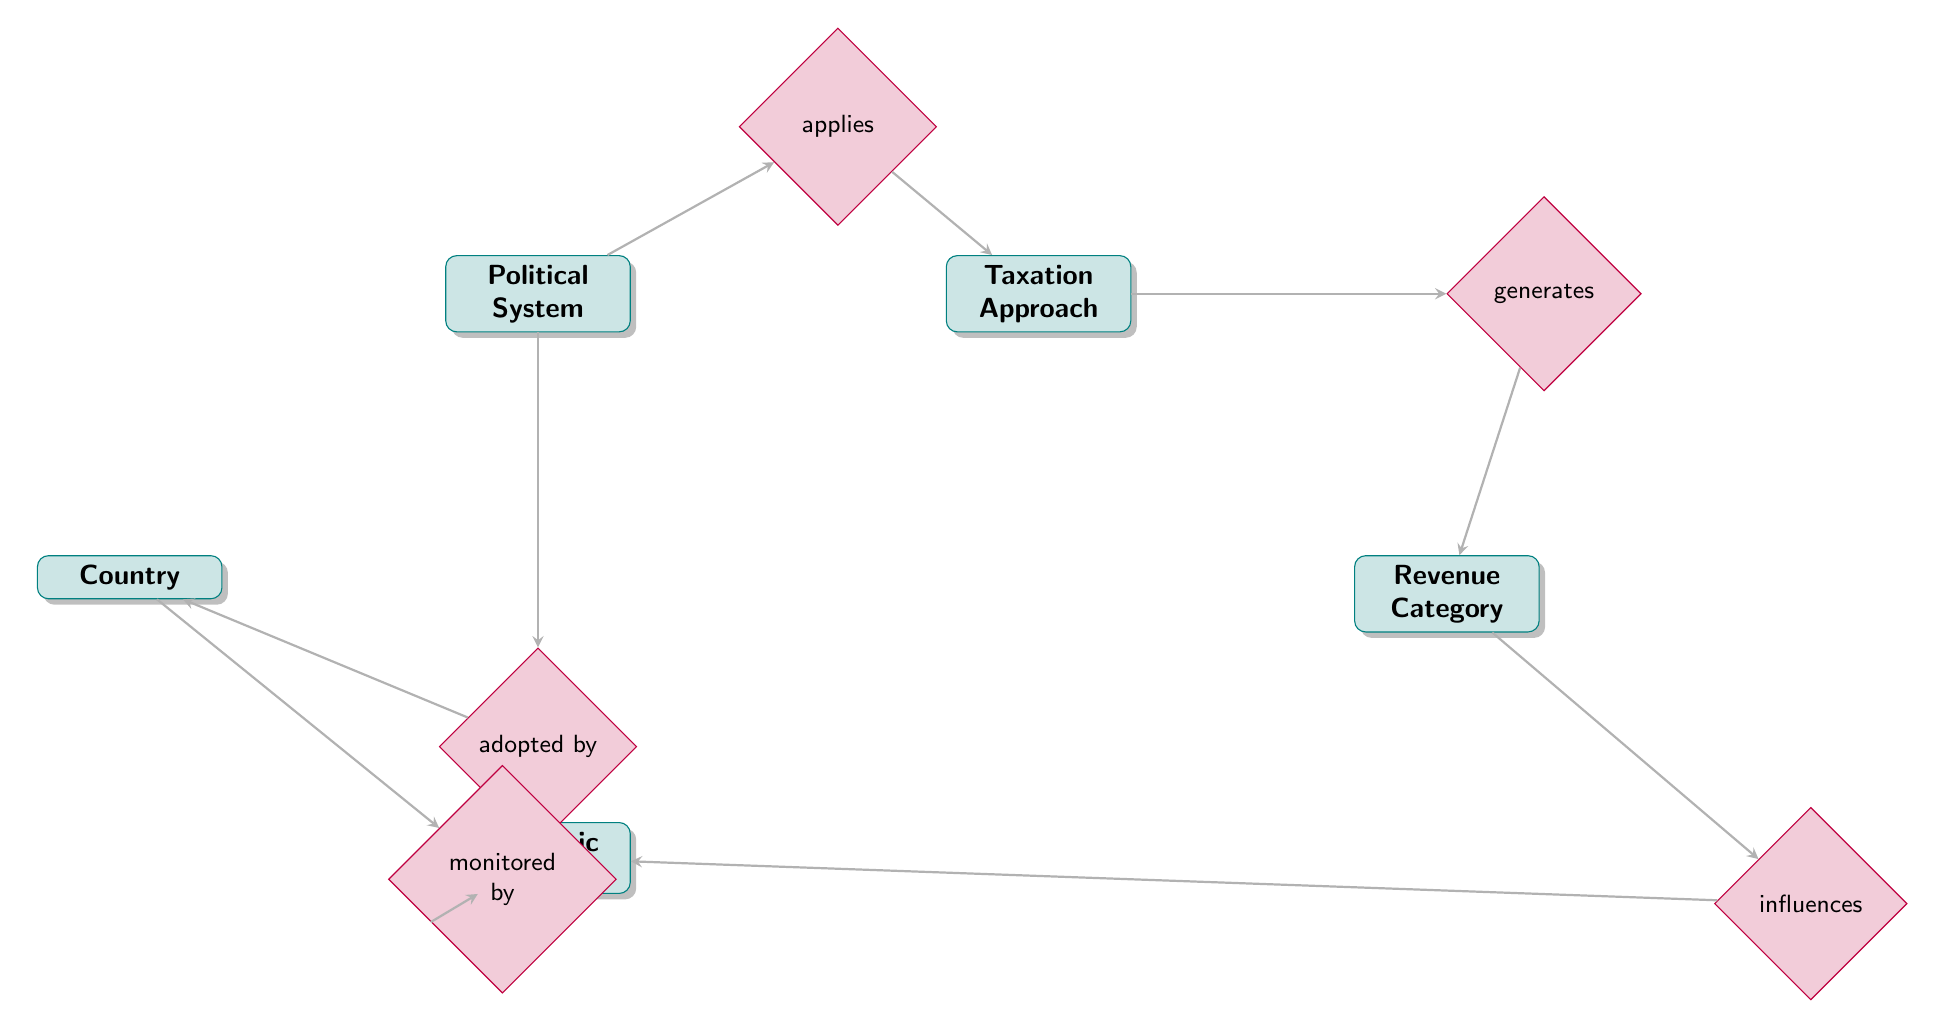What is the main entity representing different governance types? The main entity that represents various governance types in the diagram is labeled as "Political System."
Answer: Political System How many entities are connected to the "Taxation Approach" entity? The "Taxation Approach" entity is connected to two other entities: "Political System" and "Revenue Category" through the relationships "applies" and "generates," respectively.
Answer: 2 What relationship connects "Country" to "Economic Indicator"? The relationship that connects "Country" to "Economic Indicator" is labeled as "monitored by."
Answer: monitored by What attribute of "Taxation Approach" describes its function? The attribute of "Taxation Approach" that describes its function is "Description," which provides insight into how each approach operates.
Answer: Description Which entity directly influences "Economic Indicator"? The "Revenue Category" entity directly influences "Economic Indicator" through the relationship labeled as "influences."
Answer: Revenue Category Identify the relationship that involves "Political System" and "Country." The relationship that involves "Political System" and "Country" is labeled as "adopted by."
Answer: adopted by What is the number of relationships illustrated in the diagram? The diagram illustrates five relationships: "applies," "generates," "influences," "adopted by," and "monitored by."
Answer: 5 Which entity is responsible for generating revenue? The entity that is responsible for generating revenue is "Taxation Approach." This is derived from the relationship labeled "generates" which connects it to "Revenue Category."
Answer: Taxation Approach What does the "ImpactOnEconomy" attribute describe? The "ImpactOnEconomy" attribute in the "Revenue Category" entity describes how different categories of revenue affect the economy.
Answer: ImpactOnEconomy 